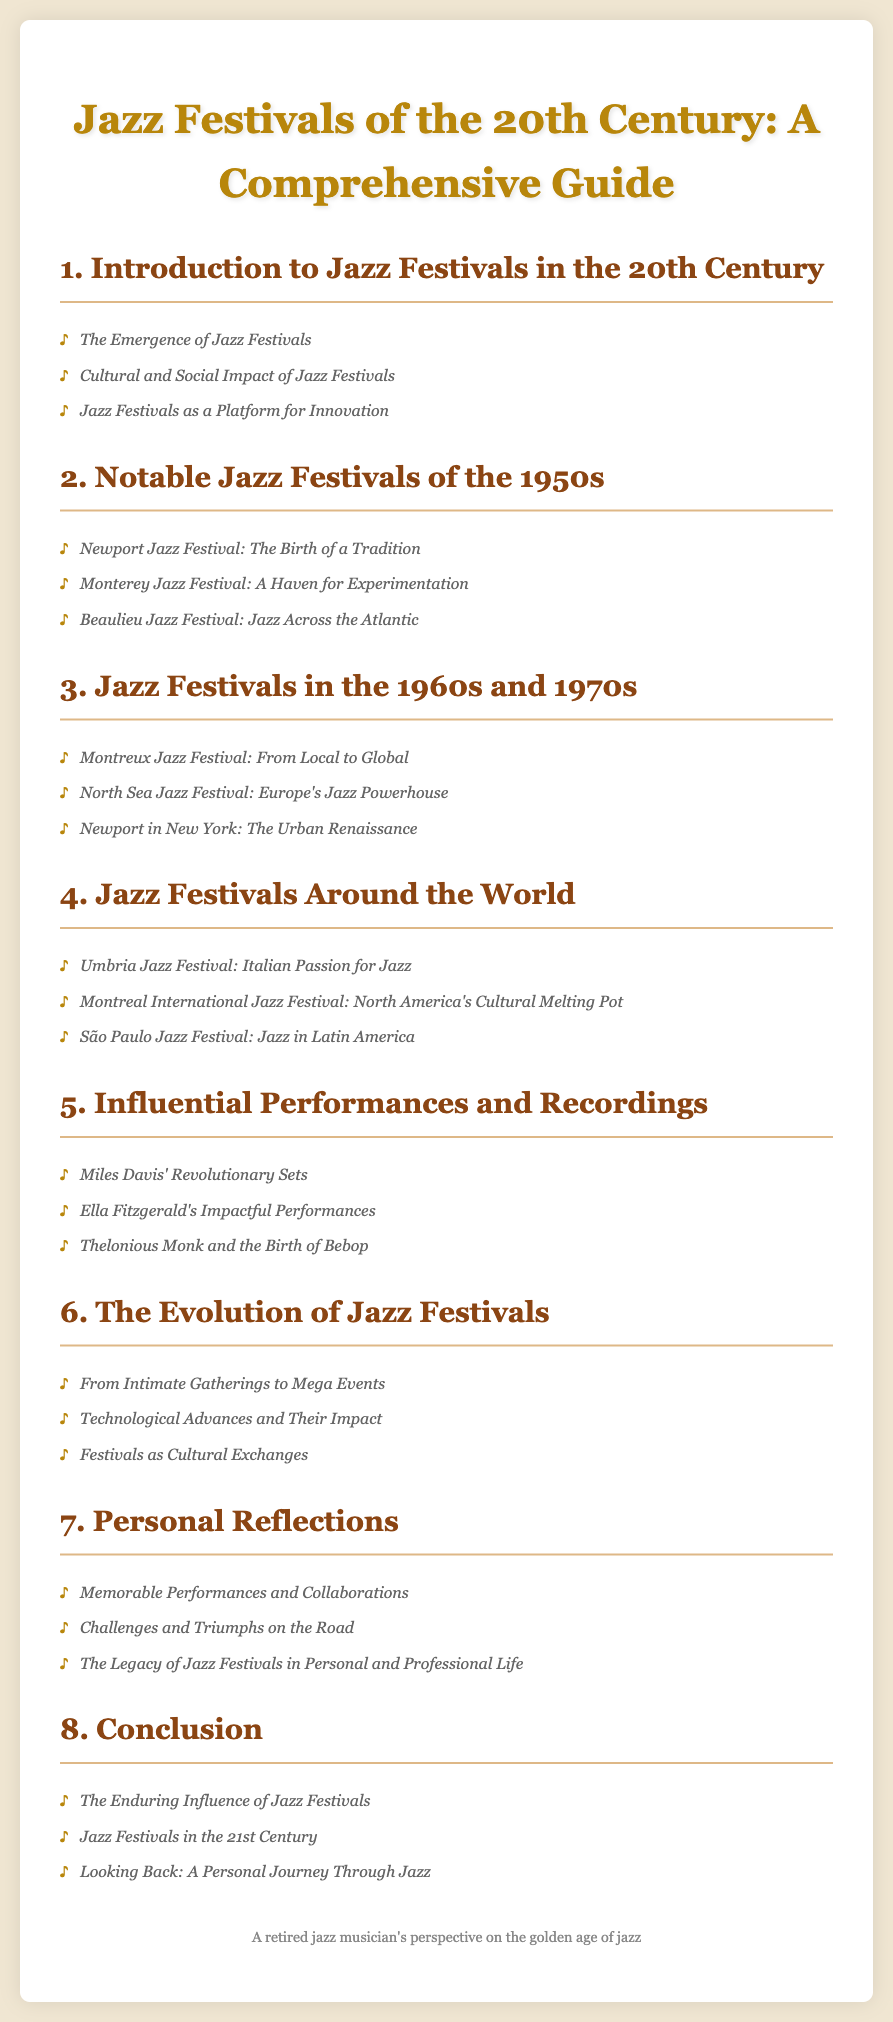What is the main title of the document? The main title appears at the top of the document and summarizes its focus, which is on Jazz Festivals from a particular era.
Answer: Jazz Festivals of the 20th Century: A Comprehensive Guide How many chapters are listed in the Table of Contents? The number of chapters can be counted directly from the document, which indicates different sections covering various topics.
Answer: Eight Which jazz festival is described as "The Birth of a Tradition"? This title refers to a specific event that plays a significant role in the development of jazz festivals, mentioned in the 1950s section.
Answer: Newport Jazz Festival What decade is highlighted for its notable jazz festivals in the document? The document specifies the 1950s as a significant decade for festivals, as indicated in the relevant chapter title.
Answer: 1950s Which jazz festival represents North America's cultural melting pot? A jazz festival is described with this phrase, reflecting its diverse cultural influences, found in the chapter about festivals around the world.
Answer: Montreal International Jazz Festival What does the chapter titled "Personal Reflections" focus on? This chapter discusses individual experiences related to jazz festivals, indicating a more personal narrative within the guide.
Answer: Memorable Performances and Collaborations What is the primary focus of Chapter 6? This chapter covers changes and developments in the nature of jazz festivals over time and their broader implications.
Answer: The Evolution of Jazz Festivals Who performed revolutionary sets that greatly influenced jazz? The document mentions a notable artist associated with groundbreaking changes in jazz, referenced in the influential performances chapter.
Answer: Miles Davis 